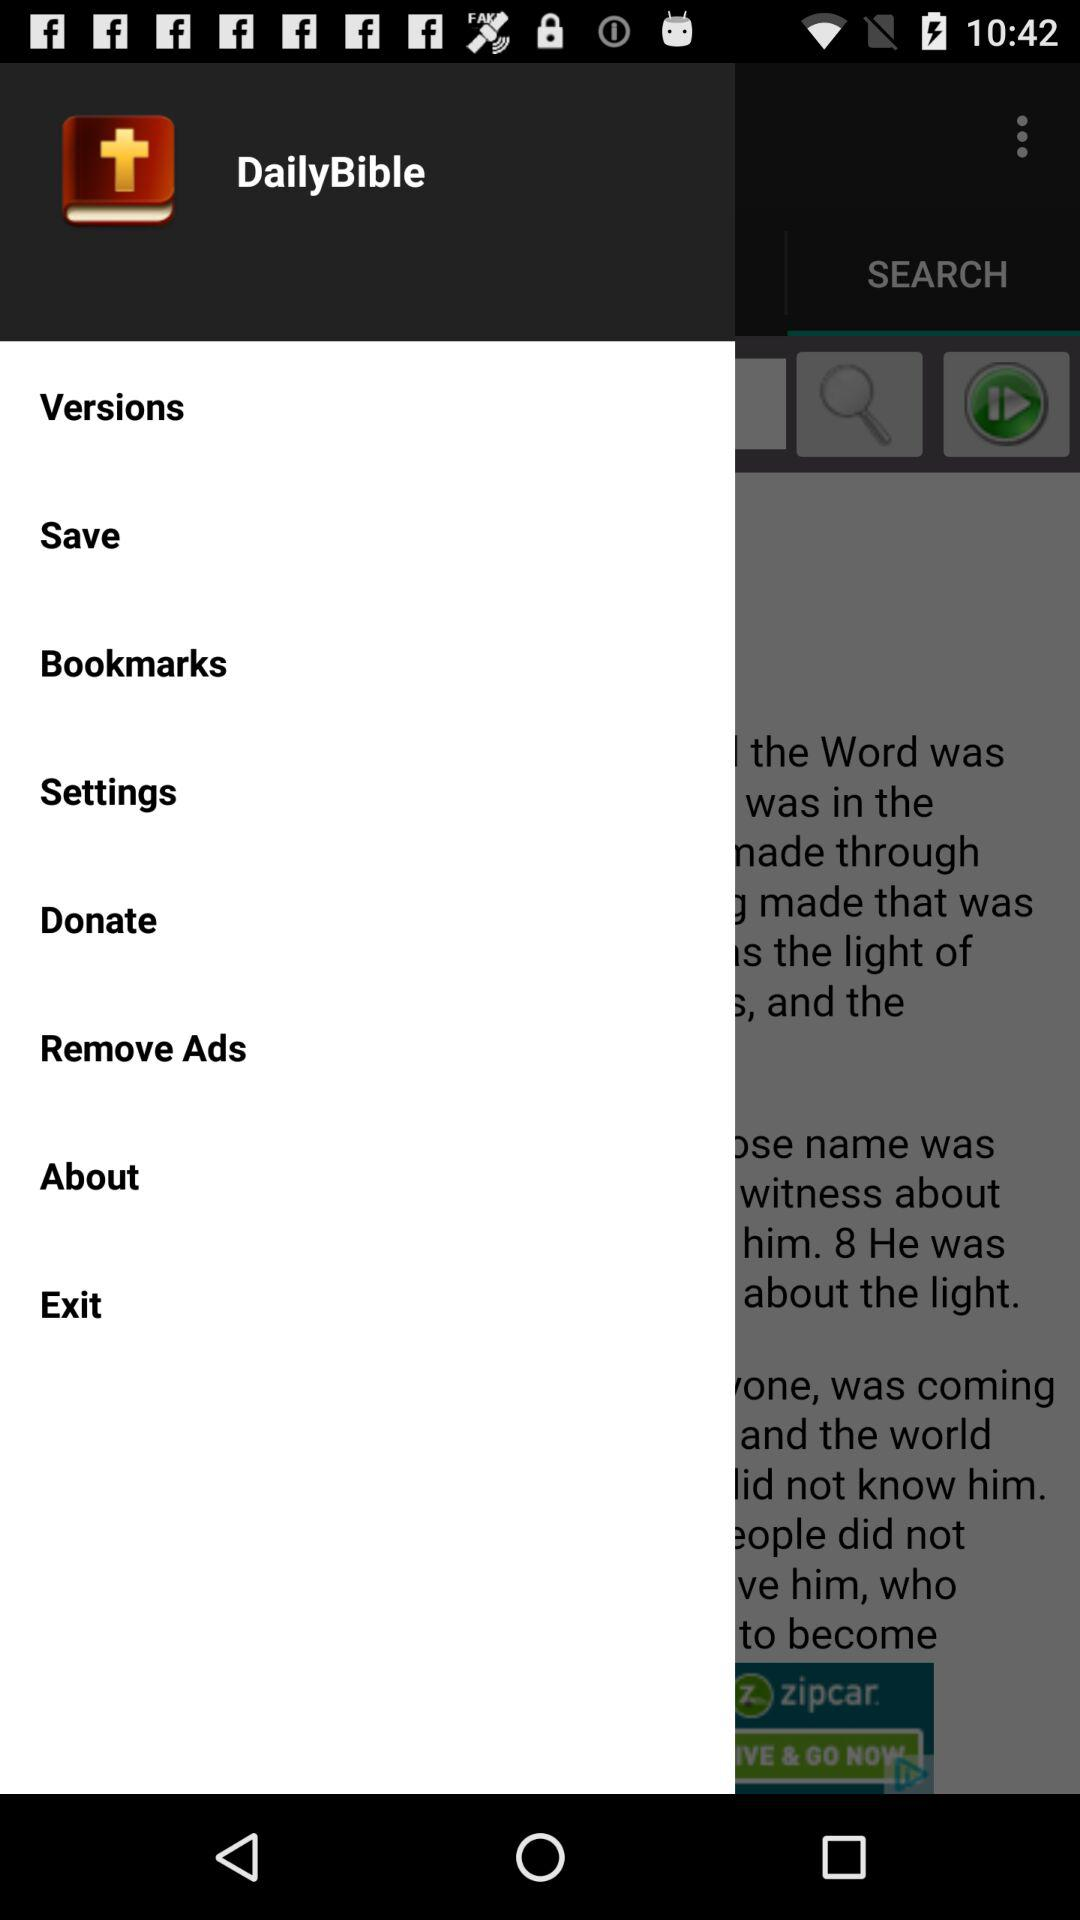What is the application name? The application name is "DailyBible". 